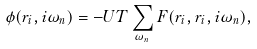Convert formula to latex. <formula><loc_0><loc_0><loc_500><loc_500>\phi ( { r } _ { i } , i \omega _ { n } ) = - U T \sum _ { \omega _ { n } } F ( { r } _ { i } , { r } _ { i } , i \omega _ { n } ) ,</formula> 